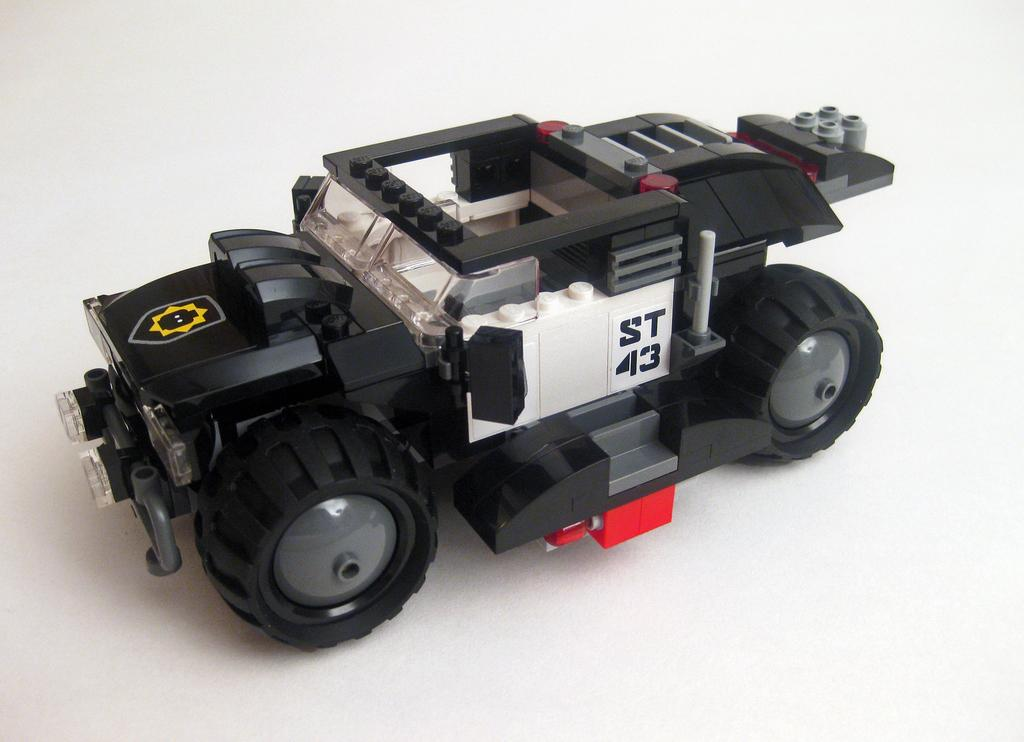What is the main subject of the picture? The main subject of the picture is a toy car. What is the color of the toy car? The toy car is black in color. Where is the toy car located in the picture? The toy car is kept on a table. Can you tell me how many seeds are in the toy car? There are no seeds present in the image, as it features a toy car and not any seeds. 